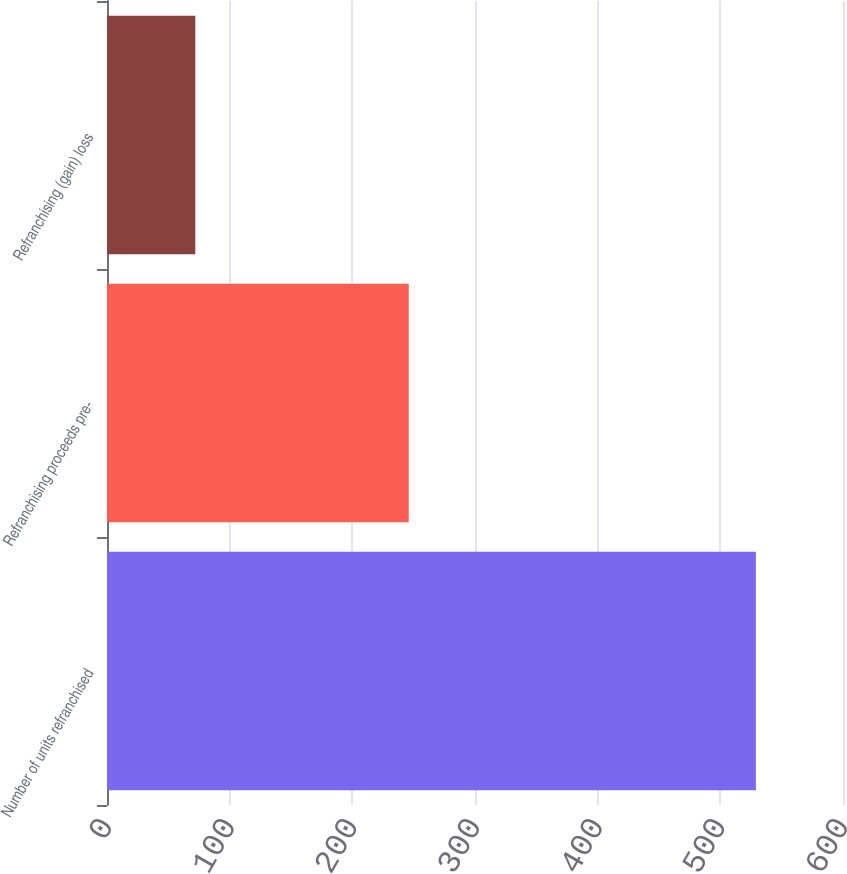Convert chart. <chart><loc_0><loc_0><loc_500><loc_500><bar_chart><fcel>Number of units refranchised<fcel>Refranchising proceeds pre-<fcel>Refranchising (gain) loss<nl><fcel>529<fcel>246<fcel>72<nl></chart> 